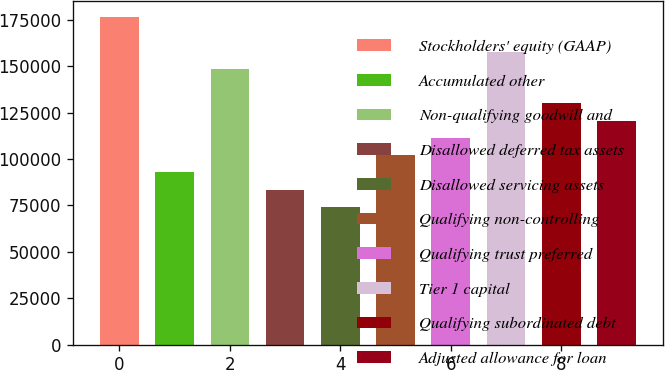<chart> <loc_0><loc_0><loc_500><loc_500><bar_chart><fcel>Stockholders' equity (GAAP)<fcel>Accumulated other<fcel>Non-qualifying goodwill and<fcel>Disallowed deferred tax assets<fcel>Disallowed servicing assets<fcel>Qualifying non-controlling<fcel>Qualifying trust preferred<fcel>Tier 1 capital<fcel>Qualifying subordinated debt<fcel>Adjusted allowance for loan<nl><fcel>176339<fcel>92811<fcel>148496<fcel>83530.1<fcel>74249.2<fcel>102092<fcel>111373<fcel>157777<fcel>129935<fcel>120654<nl></chart> 